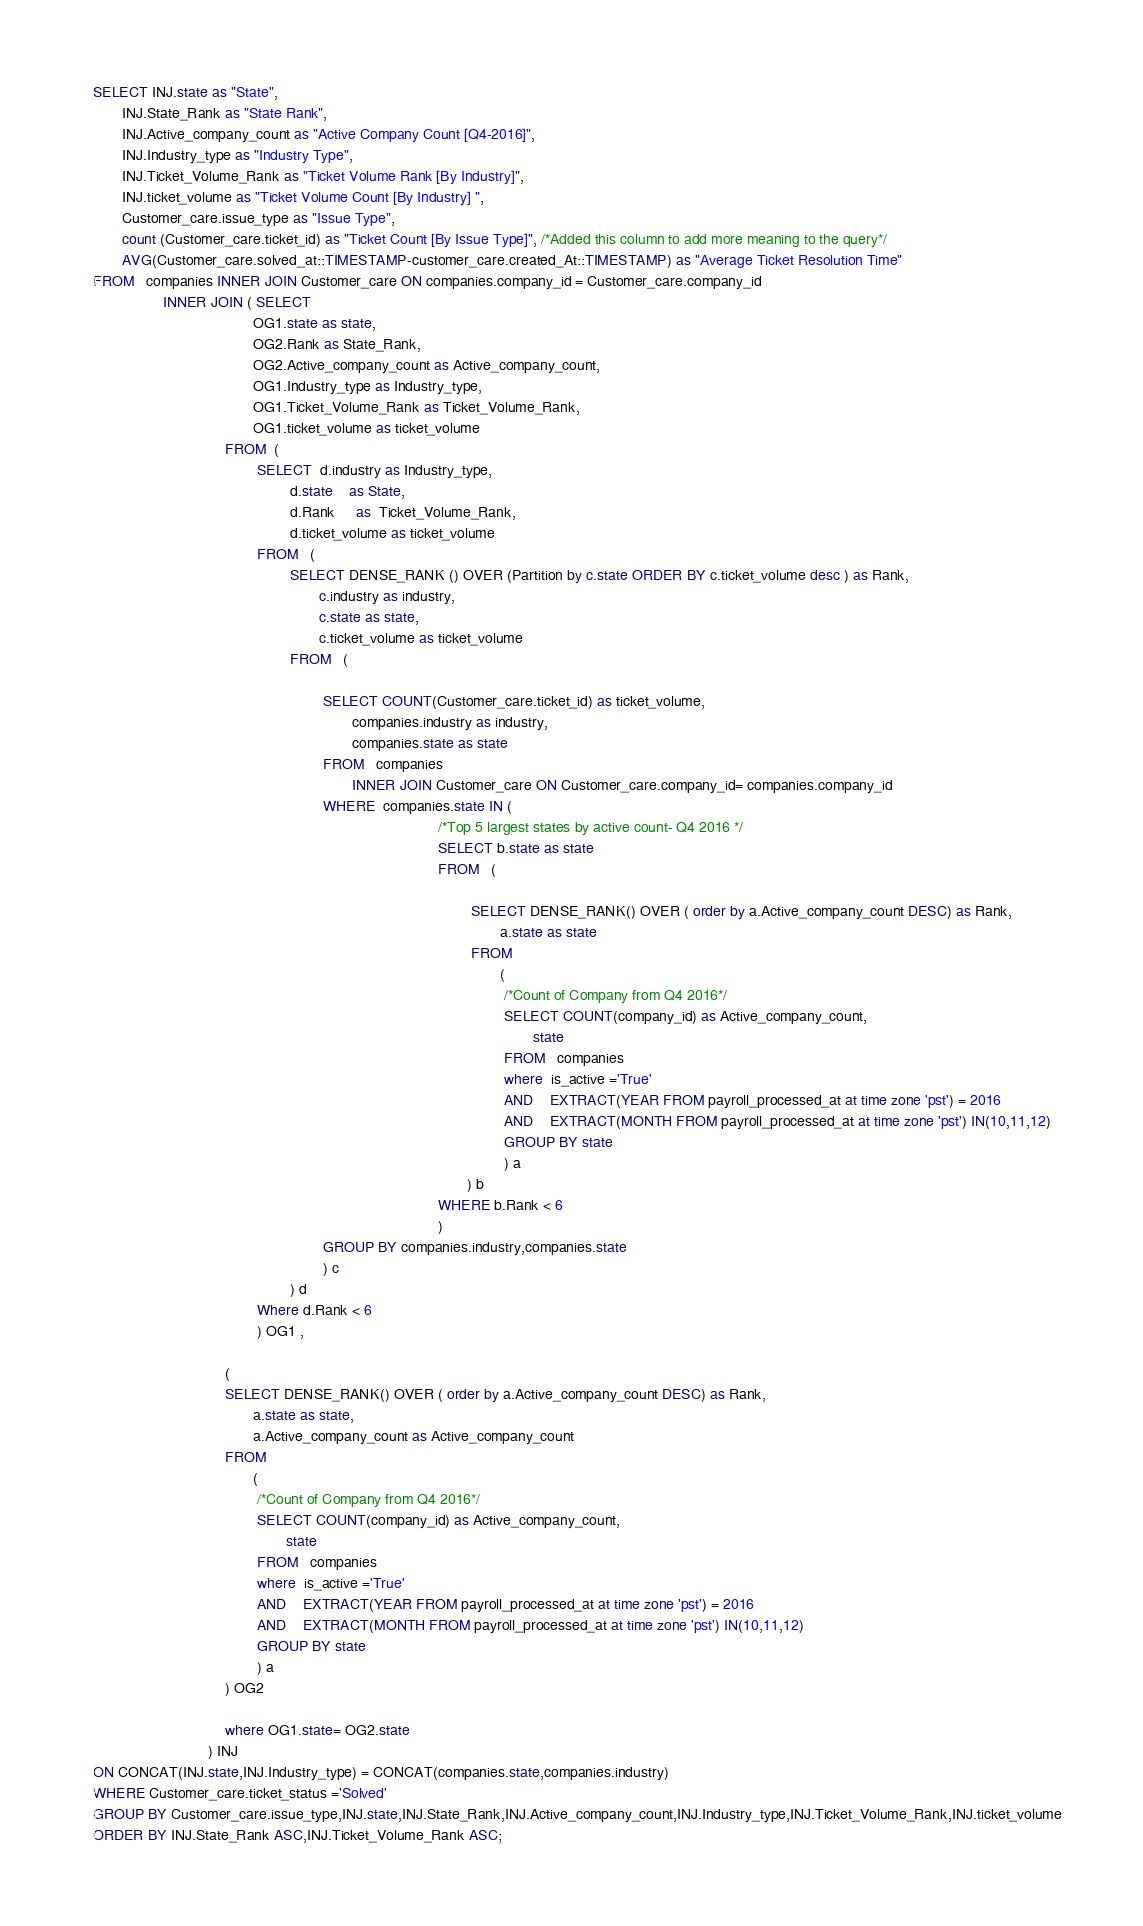<code> <loc_0><loc_0><loc_500><loc_500><_SQL_>SELECT INJ.state as "State",
       INJ.State_Rank as "State Rank",
       INJ.Active_company_count as "Active Company Count [Q4-2016]",
       INJ.Industry_type as "Industry Type",
       INJ.Ticket_Volume_Rank as "Ticket Volume Rank [By Industry]",
       INJ.ticket_volume as "Ticket Volume Count [By Industry] ",
       Customer_care.issue_type as "Issue Type",
       count (Customer_care.ticket_id) as "Ticket Count [By Issue Type]", /*Added this column to add more meaning to the query*/
       AVG(Customer_care.solved_at::TIMESTAMP-customer_care.created_At::TIMESTAMP) as "Average Ticket Resolution Time"
FROM   companies INNER JOIN Customer_care ON companies.company_id = Customer_care.company_id
                 INNER JOIN ( SELECT 
								       OG1.state as state,
								       OG2.Rank as State_Rank,
								       OG2.Active_company_count as Active_company_count,
								       OG1.Industry_type as Industry_type,
								       OG1.Ticket_Volume_Rank as Ticket_Volume_Rank,
								       OG1.ticket_volume as ticket_volume
								FROM  (       
										SELECT  d.industry as Industry_type,
										        d.state    as State,
										        d.Rank     as  Ticket_Volume_Rank,
										        d.ticket_volume as ticket_volume
										FROM   (
												SELECT DENSE_RANK () OVER (Partition by c.state ORDER BY c.ticket_volume desc ) as Rank,
												       c.industry as industry,
												       c.state as state,
												       c.ticket_volume as ticket_volume
												FROM   (

														SELECT COUNT(Customer_care.ticket_id) as ticket_volume,
														       companies.industry as industry,
														       companies.state as state
														FROM   companies 
														       INNER JOIN Customer_care ON Customer_care.company_id= companies.company_id
														WHERE  companies.state IN (
																					/*Top 5 largest states by active count- Q4 2016 */
																					SELECT b.state as state
																					FROM   (

																							SELECT DENSE_RANK() OVER ( order by a.Active_company_count DESC) as Rank,
																							       a.state as state
																							FROM
																							       (
																									/*Count of Company from Q4 2016*/
																									SELECT COUNT(company_id) as Active_company_count,
																									       state
																									FROM   companies
																									where  is_active ='True'
																									AND    EXTRACT(YEAR FROM payroll_processed_at at time zone 'pst') = 2016
																									AND    EXTRACT(MONTH FROM payroll_processed_at at time zone 'pst') IN(10,11,12)  
																									GROUP BY state
																									) a 
																					       ) b
																					WHERE b.Rank < 6
																					)
														GROUP BY companies.industry,companies.state
														) c
												) d
										Where d.Rank < 6
										) OG1 ,

								(
								SELECT DENSE_RANK() OVER ( order by a.Active_company_count DESC) as Rank,
								       a.state as state,
								       a.Active_company_count as Active_company_count
								FROM
								       (
										/*Count of Company from Q4 2016*/
										SELECT COUNT(company_id) as Active_company_count,
										       state
										FROM   companies
										where  is_active ='True'
										AND    EXTRACT(YEAR FROM payroll_processed_at at time zone 'pst') = 2016
										AND    EXTRACT(MONTH FROM payroll_processed_at at time zone 'pst') IN(10,11,12)  
										GROUP BY state
										) a 
								) OG2

								where OG1.state= OG2.state
							) INJ
ON CONCAT(INJ.state,INJ.Industry_type) = CONCAT(companies.state,companies.industry)
WHERE Customer_care.ticket_status ='Solved' 
GROUP BY Customer_care.issue_type,INJ.state,INJ.State_Rank,INJ.Active_company_count,INJ.Industry_type,INJ.Ticket_Volume_Rank,INJ.ticket_volume
ORDER BY INJ.State_Rank ASC,INJ.Ticket_Volume_Rank ASC;</code> 